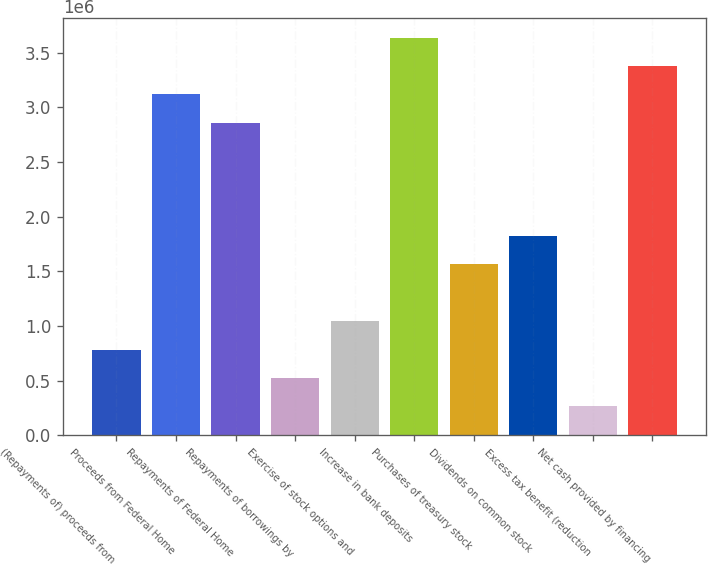Convert chart. <chart><loc_0><loc_0><loc_500><loc_500><bar_chart><fcel>(Repayments of) proceeds from<fcel>Proceeds from Federal Home<fcel>Repayments of Federal Home<fcel>Repayments of borrowings by<fcel>Exercise of stock options and<fcel>Increase in bank deposits<fcel>Purchases of treasury stock<fcel>Dividends on common stock<fcel>Excess tax benefit (reduction<fcel>Net cash provided by financing<nl><fcel>784411<fcel>3.12003e+06<fcel>2.86052e+06<fcel>524897<fcel>1.04392e+06<fcel>3.63906e+06<fcel>1.56295e+06<fcel>1.82247e+06<fcel>265384<fcel>3.37955e+06<nl></chart> 